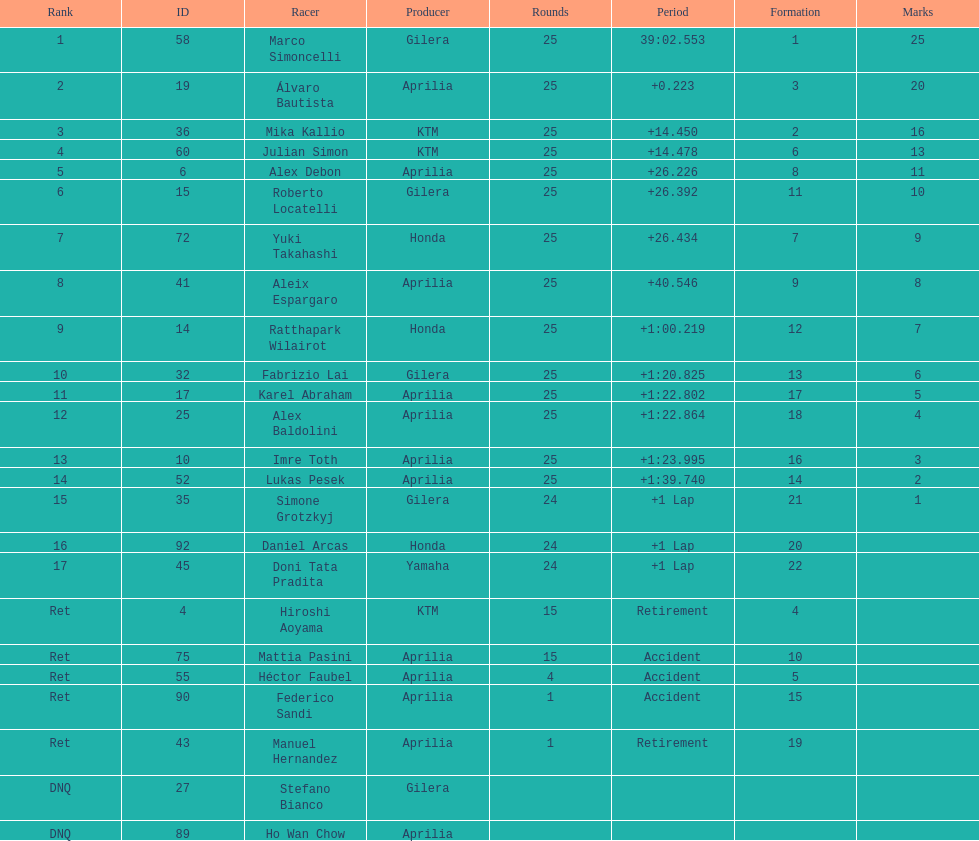Did marco simoncelli or alvaro bautista ever achieve the top ranking? Marco Simoncelli. 